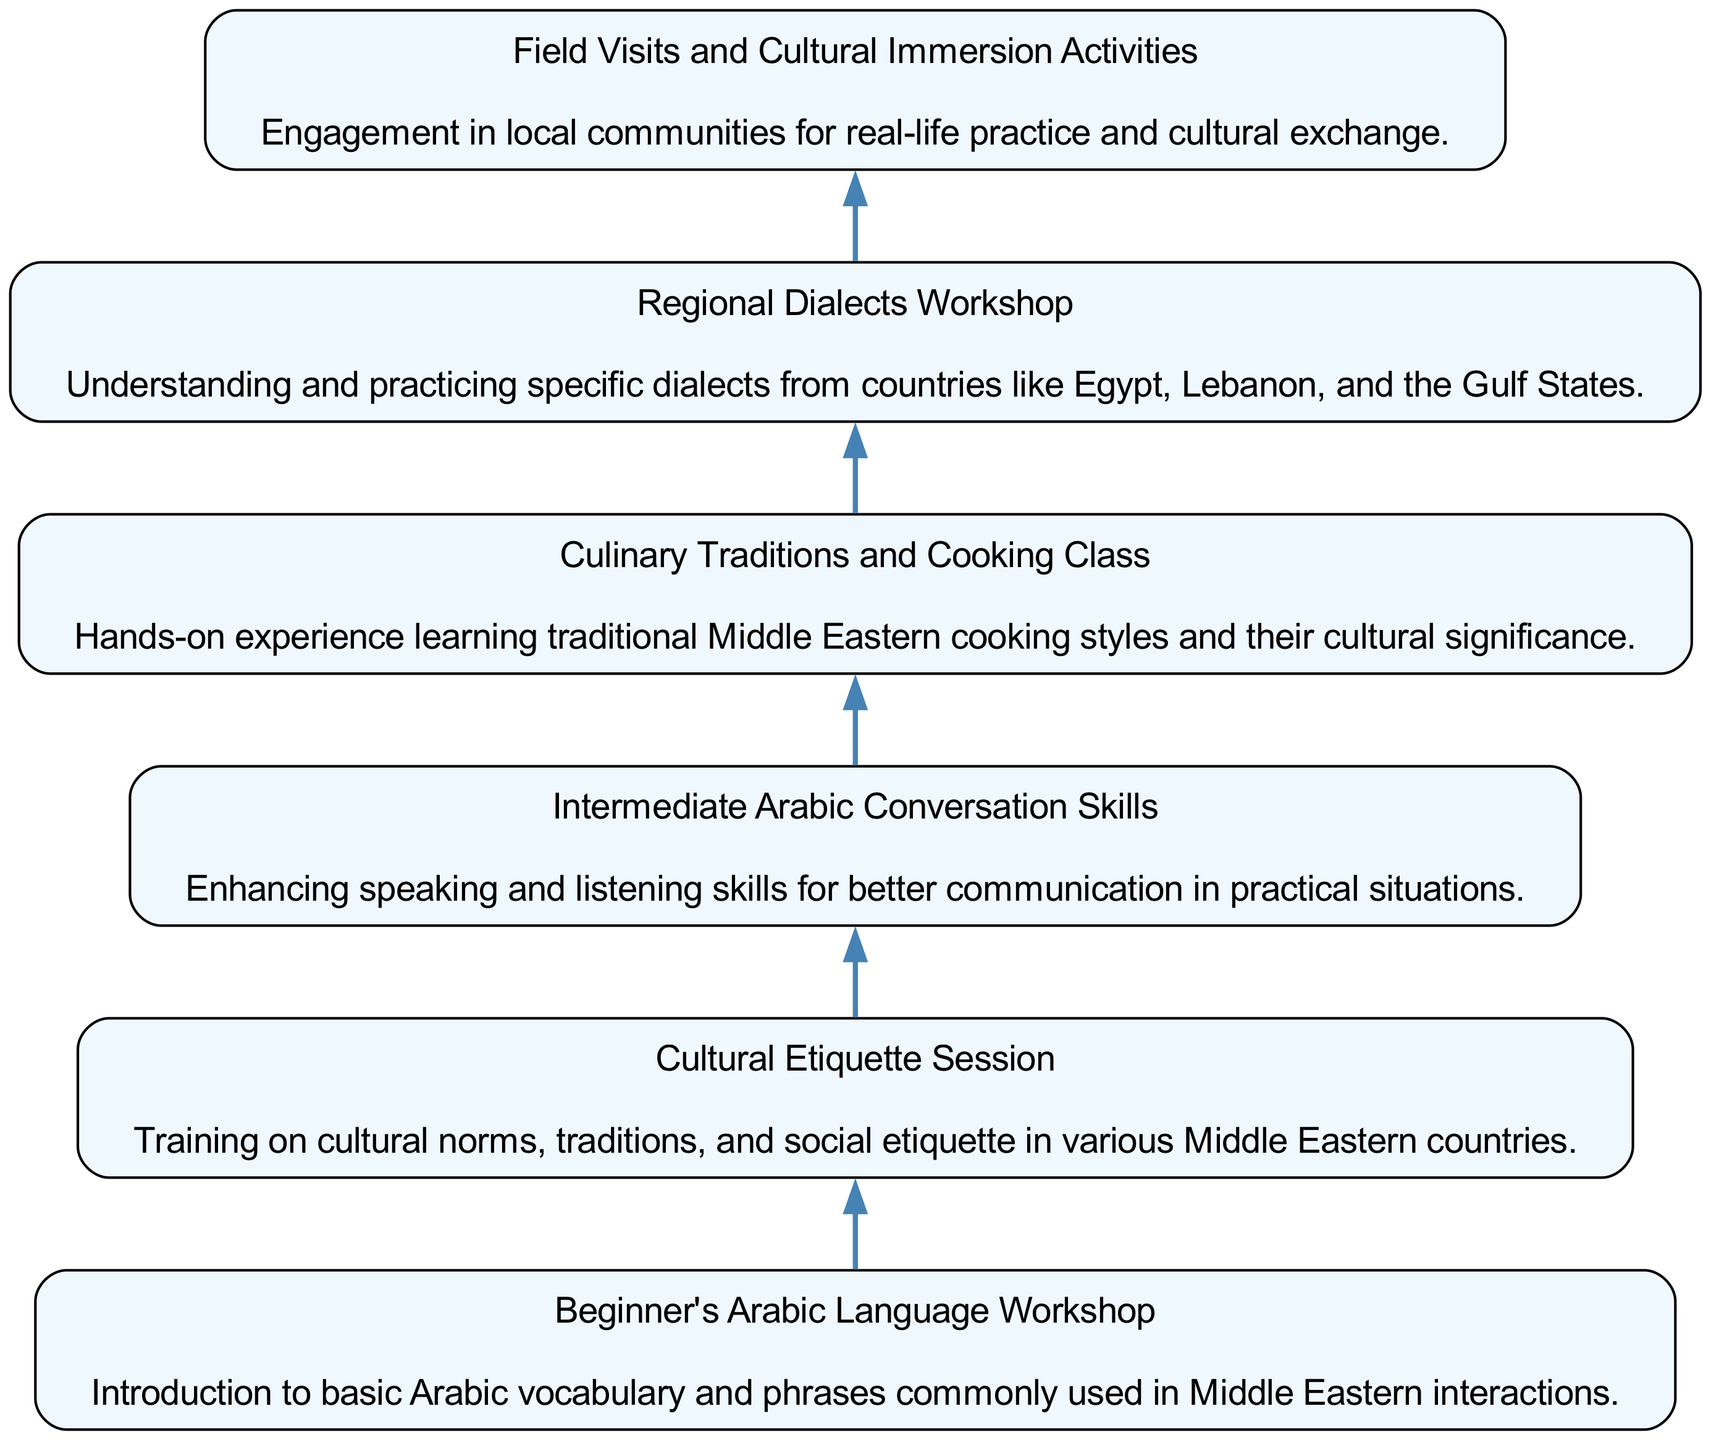What is the first workshop listed in the diagram? The diagram presents a flow of workshops starting from the bottom. The first workshop is labeled "Beginner's Arabic Language Workshop."
Answer: Beginner's Arabic Language Workshop How many workshops are included in the training schedule? By counting each individual workshop node in the diagram, there are a total of six workshops listed.
Answer: 6 What is the primary focus of the "Culinary Traditions and Cooking Class"? The description in the diagram specifies that this class focuses on learning traditional Middle Eastern cooking styles and their cultural significance.
Answer: Traditional Middle Eastern cooking styles Which workshop aims to improve practical conversation skills? Referring to the workshops, the "Intermediate Arabic Conversation Skills" workshop emphasizes enhancing speaking and listening abilities for practical communication.
Answer: Intermediate Arabic Conversation Skills What relationship exists between the "Cultural Etiquette Session" and "Field Visits and Cultural Immersion Activities"? Both of these workshops are connected in the diagram as they progress upward, indicating they are part of the same overall training structure, but they focus on different aspects—etiquette and immersion respectively.
Answer: Sequential workshops What kind of skills does the "Regional Dialects Workshop" enhance? The diagram states that this workshop is specifically designed to help participants understand and practice dialects from various Middle Eastern countries.
Answer: Understanding and practicing dialects Is the "Culinary Traditions and Cooking Class" listed before or after the "Cultural Etiquette Session"? By analyzing the flow in the diagram, the "Culinary Traditions and Cooking Class" is placed below the "Cultural Etiquette Session," indicating it comes after that session in the training schedule.
Answer: After How does the "Field Visits and Cultural Immersion Activities" relate to community engagement? The description clearly mentions that this workshop involves engagement in local communities for cultural exchange, highlighting its focus on real-life practice.
Answer: Engagement in local communities What is the purpose of the "Beginner's Arabic Language Workshop"? The purpose, as stated in the description, is to introduce basic Arabic vocabulary and phrases that are commonly used in Middle Eastern interactions.
Answer: Introduction to basic Arabic vocabulary and phrases 